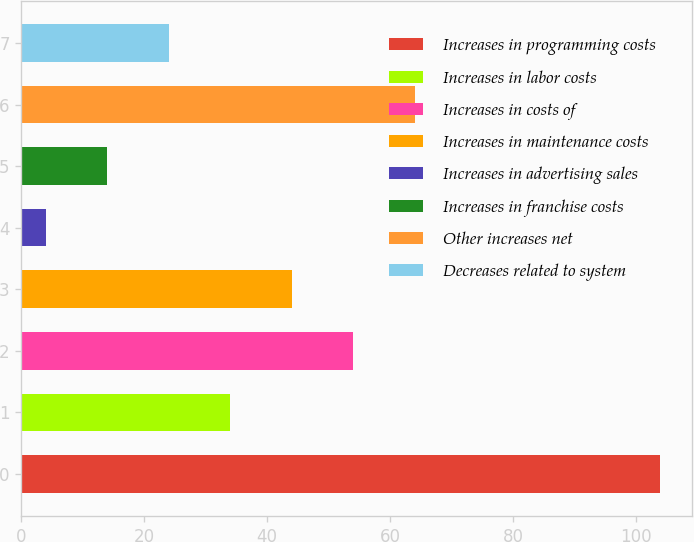Convert chart to OTSL. <chart><loc_0><loc_0><loc_500><loc_500><bar_chart><fcel>Increases in programming costs<fcel>Increases in labor costs<fcel>Increases in costs of<fcel>Increases in maintenance costs<fcel>Increases in advertising sales<fcel>Increases in franchise costs<fcel>Other increases net<fcel>Decreases related to system<nl><fcel>104<fcel>34<fcel>54<fcel>44<fcel>4<fcel>14<fcel>64<fcel>24<nl></chart> 